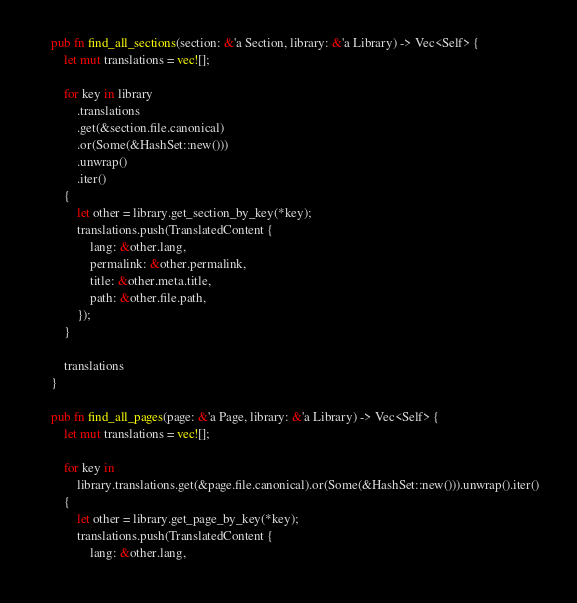<code> <loc_0><loc_0><loc_500><loc_500><_Rust_>    pub fn find_all_sections(section: &'a Section, library: &'a Library) -> Vec<Self> {
        let mut translations = vec![];

        for key in library
            .translations
            .get(&section.file.canonical)
            .or(Some(&HashSet::new()))
            .unwrap()
            .iter()
        {
            let other = library.get_section_by_key(*key);
            translations.push(TranslatedContent {
                lang: &other.lang,
                permalink: &other.permalink,
                title: &other.meta.title,
                path: &other.file.path,
            });
        }

        translations
    }

    pub fn find_all_pages(page: &'a Page, library: &'a Library) -> Vec<Self> {
        let mut translations = vec![];

        for key in
            library.translations.get(&page.file.canonical).or(Some(&HashSet::new())).unwrap().iter()
        {
            let other = library.get_page_by_key(*key);
            translations.push(TranslatedContent {
                lang: &other.lang,</code> 